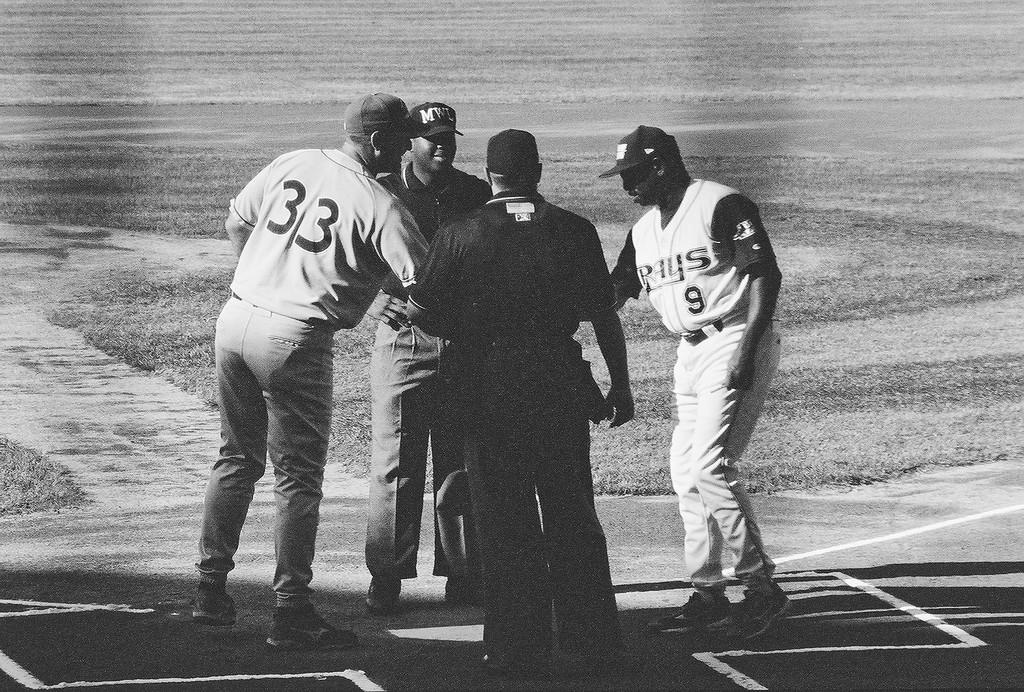What is the shirt number of the player on the left?
Give a very brief answer. 33. What team is on the right?
Your response must be concise. Rays. 